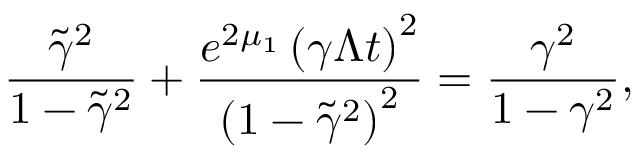Convert formula to latex. <formula><loc_0><loc_0><loc_500><loc_500>\frac { \tilde { \gamma } ^ { 2 } } { 1 - \tilde { \gamma } ^ { 2 } } + \frac { e ^ { 2 \mu _ { 1 } } \left ( \gamma \Lambda t \right ) ^ { 2 } } { \left ( 1 - \tilde { \gamma } ^ { 2 } \right ) ^ { 2 } } = \frac { \gamma ^ { 2 } } { 1 - \gamma ^ { 2 } } ,</formula> 